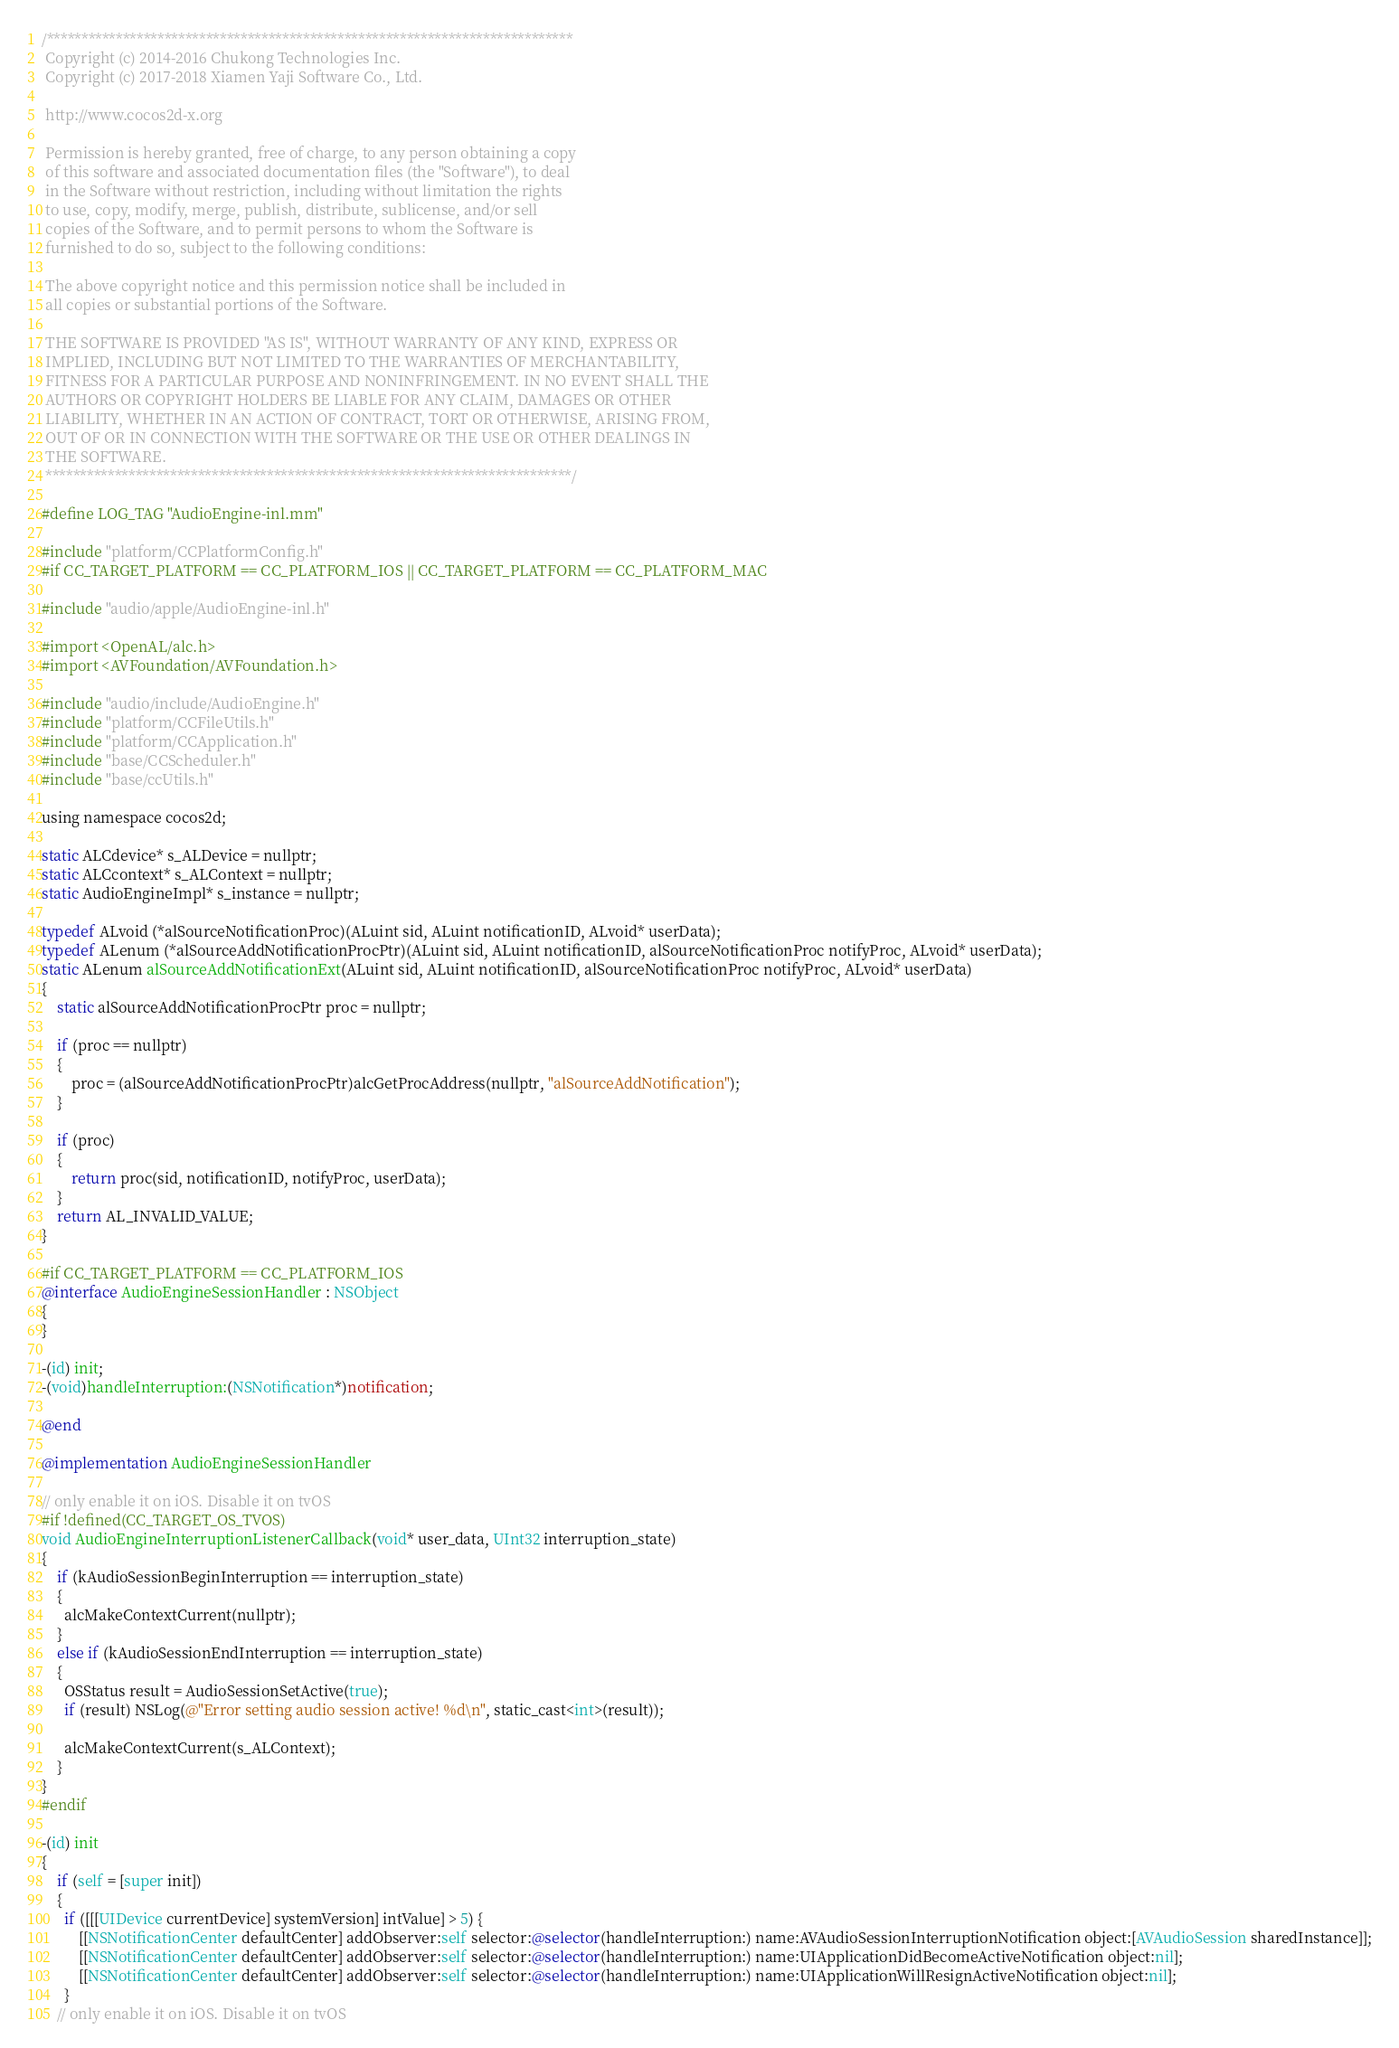Convert code to text. <code><loc_0><loc_0><loc_500><loc_500><_ObjectiveC_>/****************************************************************************
 Copyright (c) 2014-2016 Chukong Technologies Inc.
 Copyright (c) 2017-2018 Xiamen Yaji Software Co., Ltd.

 http://www.cocos2d-x.org

 Permission is hereby granted, free of charge, to any person obtaining a copy
 of this software and associated documentation files (the "Software"), to deal
 in the Software without restriction, including without limitation the rights
 to use, copy, modify, merge, publish, distribute, sublicense, and/or sell
 copies of the Software, and to permit persons to whom the Software is
 furnished to do so, subject to the following conditions:

 The above copyright notice and this permission notice shall be included in
 all copies or substantial portions of the Software.

 THE SOFTWARE IS PROVIDED "AS IS", WITHOUT WARRANTY OF ANY KIND, EXPRESS OR
 IMPLIED, INCLUDING BUT NOT LIMITED TO THE WARRANTIES OF MERCHANTABILITY,
 FITNESS FOR A PARTICULAR PURPOSE AND NONINFRINGEMENT. IN NO EVENT SHALL THE
 AUTHORS OR COPYRIGHT HOLDERS BE LIABLE FOR ANY CLAIM, DAMAGES OR OTHER
 LIABILITY, WHETHER IN AN ACTION OF CONTRACT, TORT OR OTHERWISE, ARISING FROM,
 OUT OF OR IN CONNECTION WITH THE SOFTWARE OR THE USE OR OTHER DEALINGS IN
 THE SOFTWARE.
 ****************************************************************************/

#define LOG_TAG "AudioEngine-inl.mm"

#include "platform/CCPlatformConfig.h"
#if CC_TARGET_PLATFORM == CC_PLATFORM_IOS || CC_TARGET_PLATFORM == CC_PLATFORM_MAC

#include "audio/apple/AudioEngine-inl.h"

#import <OpenAL/alc.h>
#import <AVFoundation/AVFoundation.h>

#include "audio/include/AudioEngine.h"
#include "platform/CCFileUtils.h"
#include "platform/CCApplication.h"
#include "base/CCScheduler.h"
#include "base/ccUtils.h"

using namespace cocos2d;

static ALCdevice* s_ALDevice = nullptr;
static ALCcontext* s_ALContext = nullptr;
static AudioEngineImpl* s_instance = nullptr;

typedef ALvoid (*alSourceNotificationProc)(ALuint sid, ALuint notificationID, ALvoid* userData);
typedef ALenum (*alSourceAddNotificationProcPtr)(ALuint sid, ALuint notificationID, alSourceNotificationProc notifyProc, ALvoid* userData);
static ALenum alSourceAddNotificationExt(ALuint sid, ALuint notificationID, alSourceNotificationProc notifyProc, ALvoid* userData)
{
    static alSourceAddNotificationProcPtr proc = nullptr;

    if (proc == nullptr)
    {
        proc = (alSourceAddNotificationProcPtr)alcGetProcAddress(nullptr, "alSourceAddNotification");
    }

    if (proc)
    {
        return proc(sid, notificationID, notifyProc, userData);
    }
    return AL_INVALID_VALUE;
}

#if CC_TARGET_PLATFORM == CC_PLATFORM_IOS
@interface AudioEngineSessionHandler : NSObject
{
}

-(id) init;
-(void)handleInterruption:(NSNotification*)notification;

@end

@implementation AudioEngineSessionHandler

// only enable it on iOS. Disable it on tvOS
#if !defined(CC_TARGET_OS_TVOS)
void AudioEngineInterruptionListenerCallback(void* user_data, UInt32 interruption_state)
{
    if (kAudioSessionBeginInterruption == interruption_state)
    {
      alcMakeContextCurrent(nullptr);
    }
    else if (kAudioSessionEndInterruption == interruption_state)
    {
      OSStatus result = AudioSessionSetActive(true);
      if (result) NSLog(@"Error setting audio session active! %d\n", static_cast<int>(result));

      alcMakeContextCurrent(s_ALContext);
    }
}
#endif

-(id) init
{
    if (self = [super init])
    {
      if ([[[UIDevice currentDevice] systemVersion] intValue] > 5) {
          [[NSNotificationCenter defaultCenter] addObserver:self selector:@selector(handleInterruption:) name:AVAudioSessionInterruptionNotification object:[AVAudioSession sharedInstance]];
          [[NSNotificationCenter defaultCenter] addObserver:self selector:@selector(handleInterruption:) name:UIApplicationDidBecomeActiveNotification object:nil];
          [[NSNotificationCenter defaultCenter] addObserver:self selector:@selector(handleInterruption:) name:UIApplicationWillResignActiveNotification object:nil];
      }
    // only enable it on iOS. Disable it on tvOS</code> 